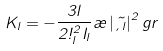Convert formula to latex. <formula><loc_0><loc_0><loc_500><loc_500>K _ { l } = - \frac { 3 l } { 2 \omega ^ { 2 } _ { l } I _ { l } } \rho \left | \vec { \xi _ { l } } \right | ^ { 2 } g r</formula> 